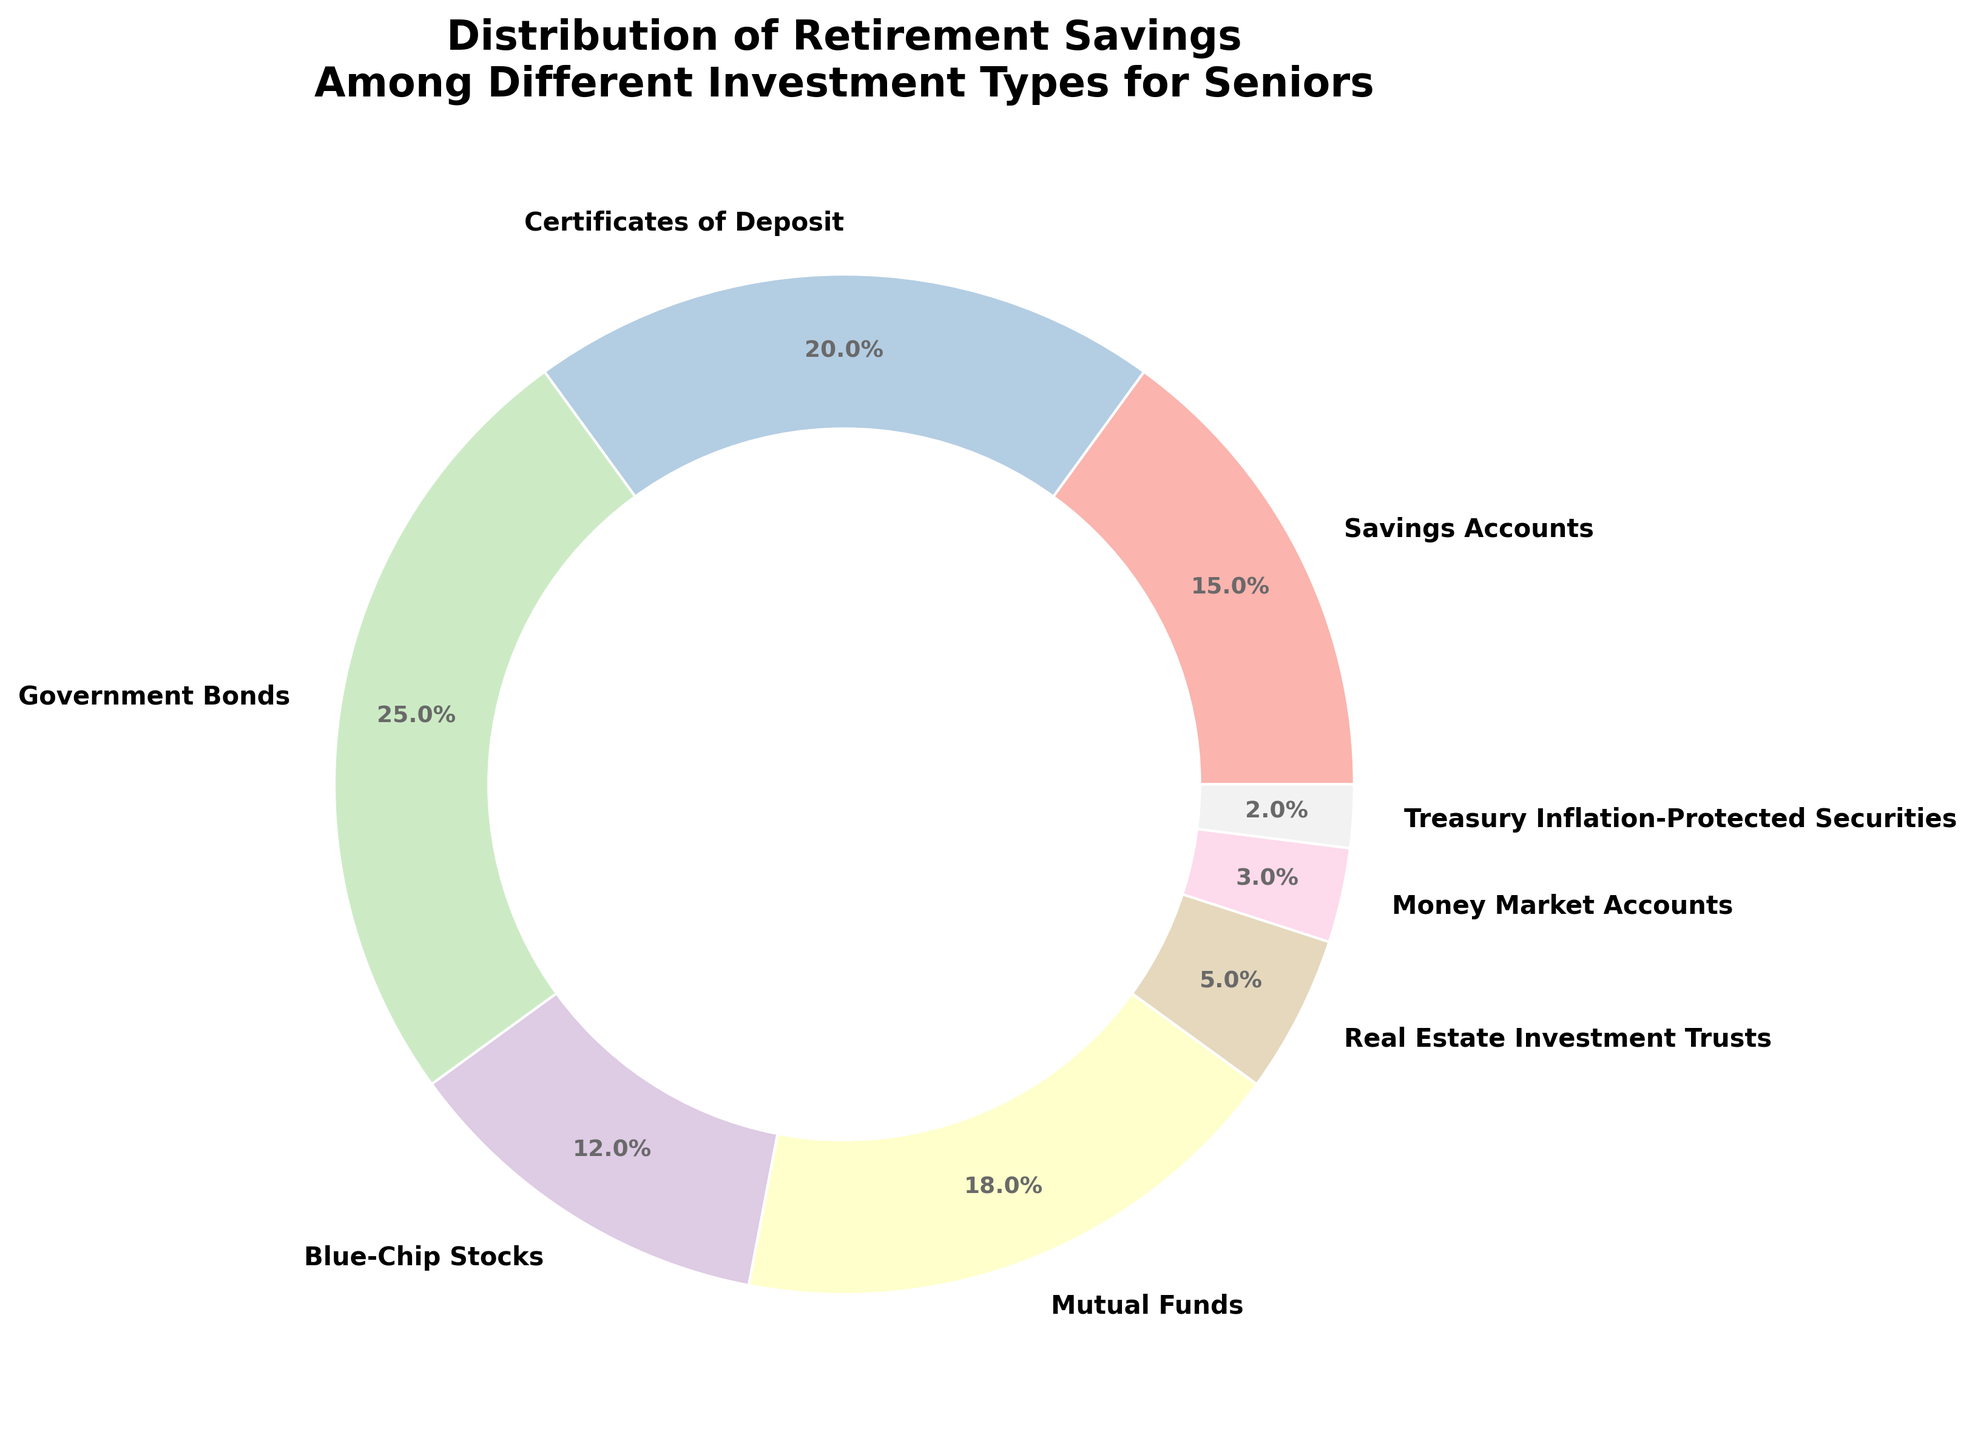What is the investment type with the highest percentage? First, locate the labels and their corresponding percentages in the pie chart. Identify the investment type with the largest percentage value. According to the data, Government Bonds have the highest percentage at 25%.
Answer: Government Bonds Which investment type has the smallest percentage? Look at the percentage values on the pie chart and find the smallest one. The smallest percentage is Treasury Inflation-Protected Securities at 2%.
Answer: Treasury Inflation-Protected Securities How much more percentage is invested in Government Bonds compared to Real Estate Investment Trusts? Find the percentages for Government Bonds (25%) and Real Estate Investment Trusts (5%). Subtract the smaller percentage from the larger one: 25% - 5% = 20%.
Answer: 20% What is the total percentage of investments in Certificates of Deposit and Blue-Chip Stocks combined? Add the percentages of Certificates of Deposit (20%) and Blue-Chip Stocks (12%): 20% + 12% = 32%.
Answer: 32% Is the percentage of investments in Mutual Funds greater than the percentage in Savings Accounts? Compare the percentages for Mutual Funds (18%) and Savings Accounts (15%). Since 18% is greater than 15%, the percentage in Mutual Funds is indeed higher.
Answer: Yes Which investment type appears in green color (or the closest color to green)? Visually locate the segment with the color closest to green. We know from the color scheme used in the code that Pastel1's palette includes green for certain segments. Inspect all segments for the green color; here, Real Estate Investment Trusts are closely green in the Pastel1 palette.
Answer: Real Estate Investment Trusts What is the combined percentage of investments in Savings Accounts, Government Bonds, and Treasury Inflation-Protected Securities? Add the percentages for Savings Accounts (15%), Government Bonds (25%), and Treasury Inflation-Protected Securities (2%): 15% + 25% + 2% = 42%.
Answer: 42% Which investment type has a percentage that is double the percentage of Money Market Accounts? Identify the percentage of Money Market Accounts (3%). Find the investment type with double this value: 3% * 2 = 6%. None match exactly, but Real Estate Investment Trusts is close with 5%.
Answer: Real Estate Investment Trusts What is the average percentage of investments in Certificates of Deposit, Blue-Chip Stocks, and Mutual Funds? Add the percentages of these three types: 20% (Certificates of Deposit) + 12% (Blue-Chip Stocks) + 18% (Mutual Funds) = 50%. Calculate the average by dividing by 3: 50% / 3 ≈ 16.67%.
Answer: 16.67% Are Money Market Accounts allocated more or less than 5% of the total investments? Look at the percentage of Money Market Accounts (3%) and compare it to 5%. Since 3% is less than 5%, they are allocated less than 5%.
Answer: Less 